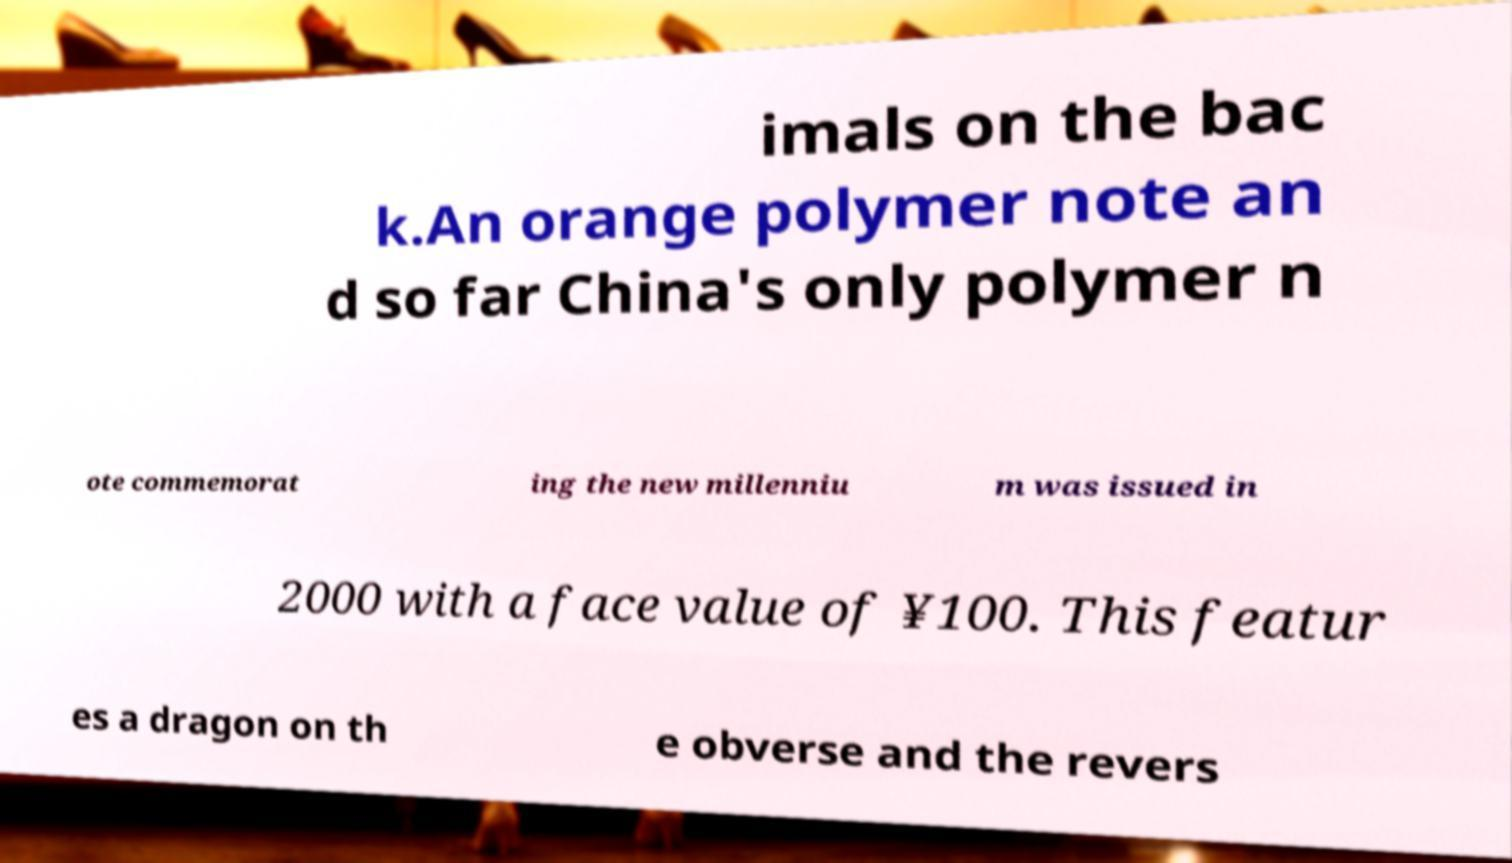I need the written content from this picture converted into text. Can you do that? imals on the bac k.An orange polymer note an d so far China's only polymer n ote commemorat ing the new millenniu m was issued in 2000 with a face value of ¥100. This featur es a dragon on th e obverse and the revers 